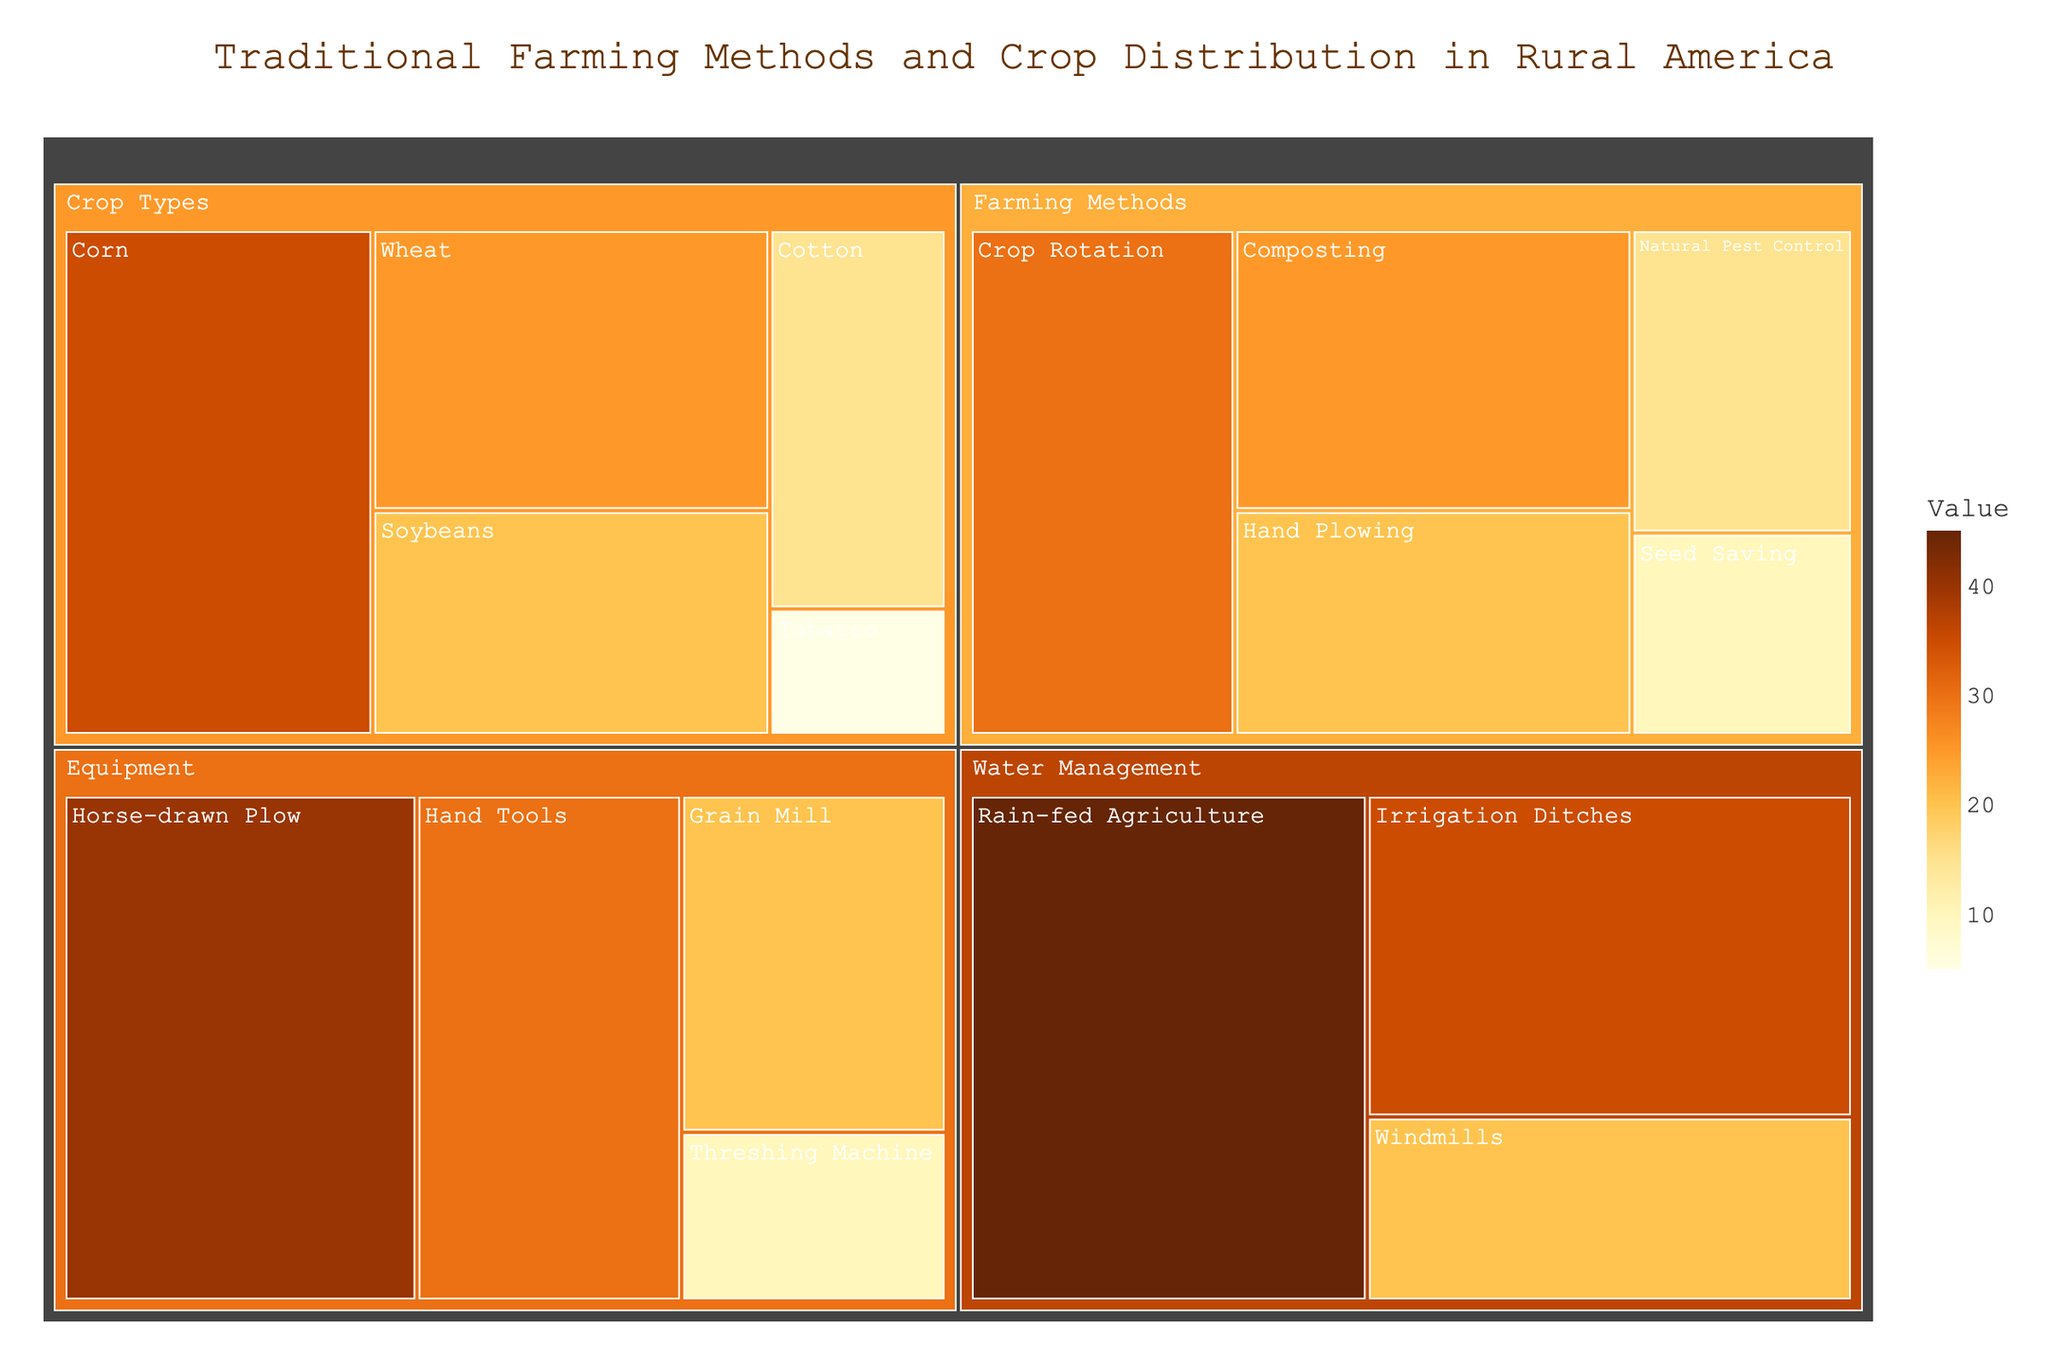How many subcategories are there under the "Crop Types" category? By inspecting the "Crop Types" section of the treemap, you can count the distinct subcategories listed.
Answer: 5 Which subcategory has the highest value in the "Farming Methods" category? Look at the "Farming Methods" section and compare the values of each subcategory to identify the highest one.
Answer: Crop Rotation What is the total value for all equipment-related subcategories? Sum the values of all subcategories under the "Equipment" category: (40 + 30 + 20 + 10).
Answer: 100 Is the value of "Horse-drawn Plow" higher than "Natural Pest Control"? Compare the values for "Horse-drawn Plow" and "Natural Pest Control" displayed in their respective boxes.
Answer: Yes Which category has the highest combined value, "Water Management" or "Crop Types"? Add the values of all subcategories under "Water Management" (45 + 35 + 20) and "Crop Types" (35 + 25 + 20 + 15 + 5), then compare the sums.
Answer: Water Management What is the difference in value between "Rain-fed Agriculture" and "Irrigation Ditches"? Subtract the value of "Irrigation Ditches" from the value of "Rain-fed Agriculture": 45 - 35.
Answer: 10 Is "Seed Saving" the lowest-valued subcategory under "Farming Methods"? Examine the values of all subcategories under "Farming Methods" to see if "Seed Saving" has the smallest value.
Answer: Yes Which subcategory has the greater value, "Windmills" or "Soybeans"? Compare the values for "Windmills" and "Soybeans" displayed in their respective boxes.
Answer: Windmills Are there more subcategories in the "Farming Methods" category or the "Equipment" category? Count the distinct subcategories listed under "Farming Methods" and "Equipment" and compare the numbers.
Answer: Farming Methods What is the sum of the values for "Wheat" and "Composting"? Add the value of "Wheat" (25) and "Composting" (25).
Answer: 50 